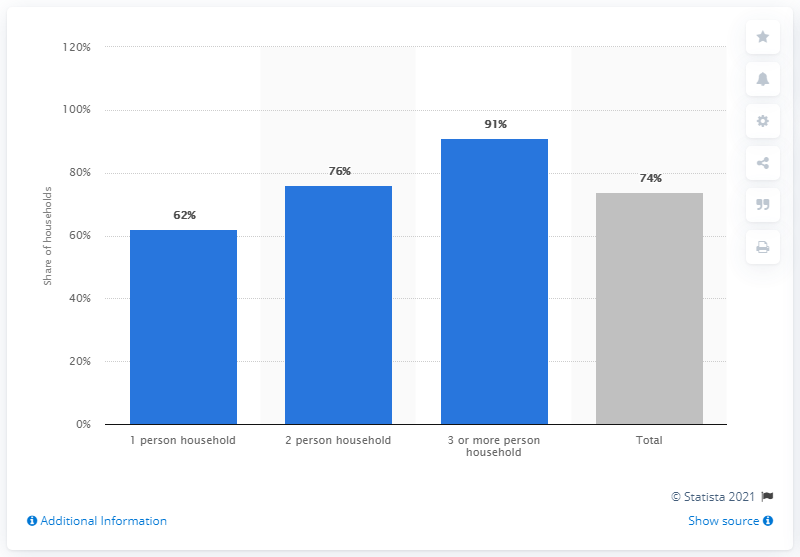Mention a couple of crucial points in this snapshot. In households with three or more people, the corresponding figure was 91%. 